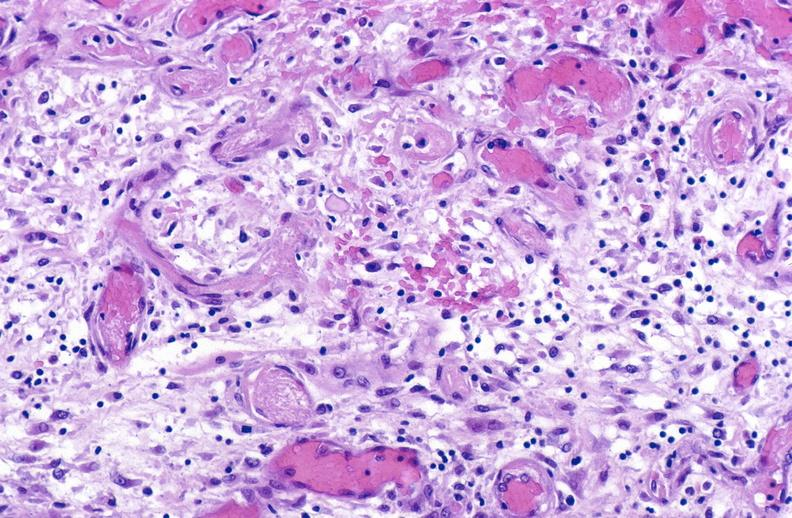s jejunum present?
Answer the question using a single word or phrase. No 